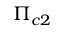Convert formula to latex. <formula><loc_0><loc_0><loc_500><loc_500>\Pi _ { c 2 }</formula> 